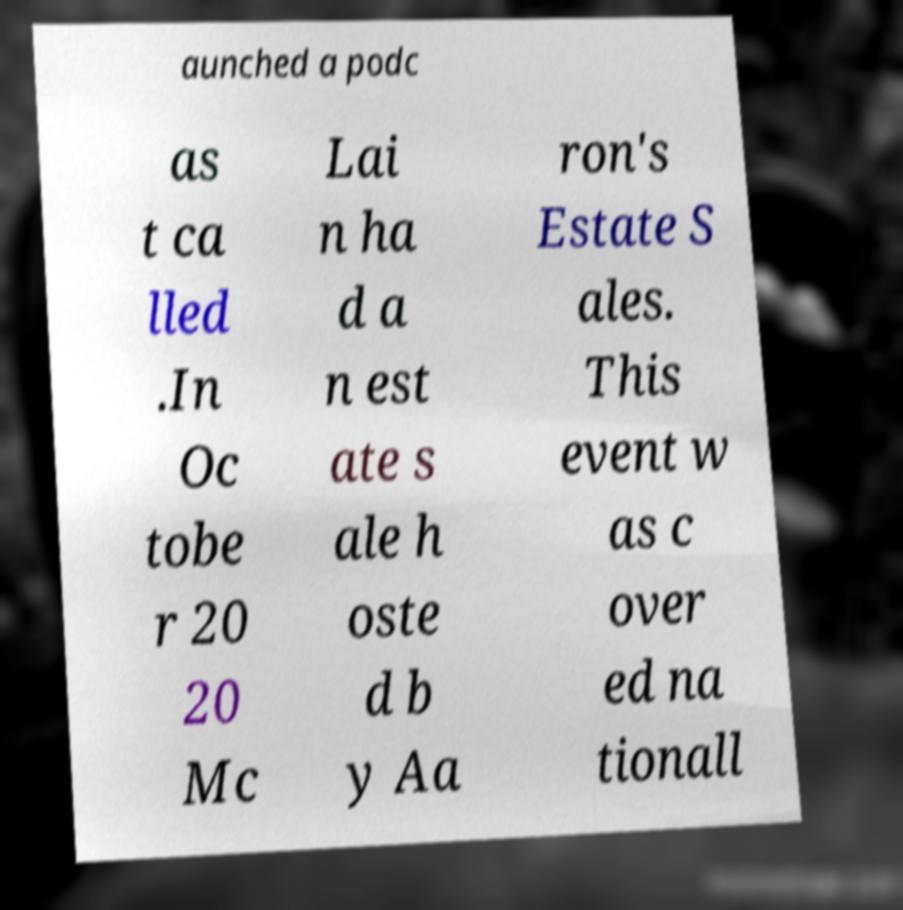I need the written content from this picture converted into text. Can you do that? aunched a podc as t ca lled .In Oc tobe r 20 20 Mc Lai n ha d a n est ate s ale h oste d b y Aa ron's Estate S ales. This event w as c over ed na tionall 